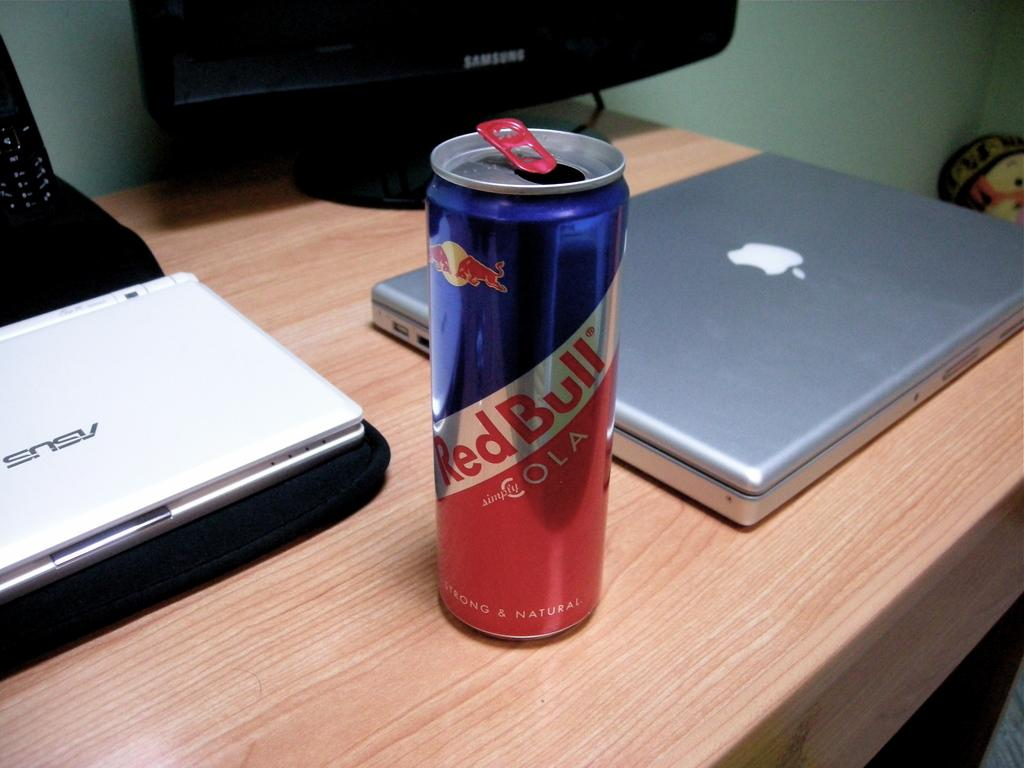<image>
Present a compact description of the photo's key features. Red Bull Cola Can that is on a table with a computer monitor and laptop. 